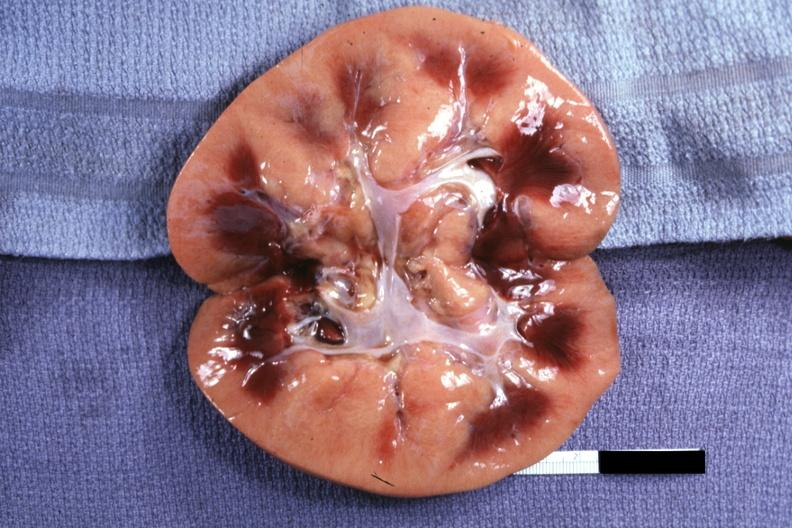what is present?
Answer the question using a single word or phrase. Transplant acute rejection 